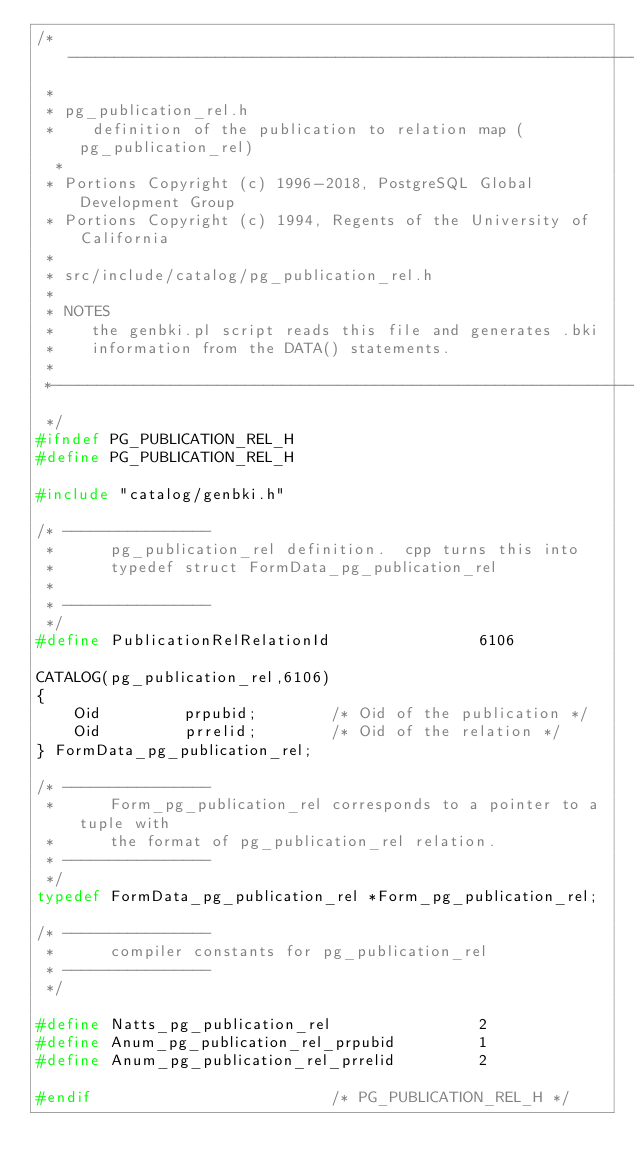Convert code to text. <code><loc_0><loc_0><loc_500><loc_500><_C_>/*-------------------------------------------------------------------------
 *
 * pg_publication_rel.h
 *	  definition of the publication to relation map (pg_publication_rel)
  *
 * Portions Copyright (c) 1996-2018, PostgreSQL Global Development Group
 * Portions Copyright (c) 1994, Regents of the University of California
 *
 * src/include/catalog/pg_publication_rel.h
 *
 * NOTES
 *	  the genbki.pl script reads this file and generates .bki
 *	  information from the DATA() statements.
 *
 *-------------------------------------------------------------------------
 */
#ifndef PG_PUBLICATION_REL_H
#define PG_PUBLICATION_REL_H

#include "catalog/genbki.h"

/* ----------------
 *		pg_publication_rel definition.  cpp turns this into
 *		typedef struct FormData_pg_publication_rel
 *
 * ----------------
 */
#define PublicationRelRelationId				6106

CATALOG(pg_publication_rel,6106)
{
	Oid			prpubid;		/* Oid of the publication */
	Oid			prrelid;		/* Oid of the relation */
} FormData_pg_publication_rel;

/* ----------------
 *		Form_pg_publication_rel corresponds to a pointer to a tuple with
 *		the format of pg_publication_rel relation.
 * ----------------
 */
typedef FormData_pg_publication_rel *Form_pg_publication_rel;

/* ----------------
 *		compiler constants for pg_publication_rel
 * ----------------
 */

#define Natts_pg_publication_rel				2
#define Anum_pg_publication_rel_prpubid			1
#define Anum_pg_publication_rel_prrelid			2

#endif							/* PG_PUBLICATION_REL_H */
</code> 